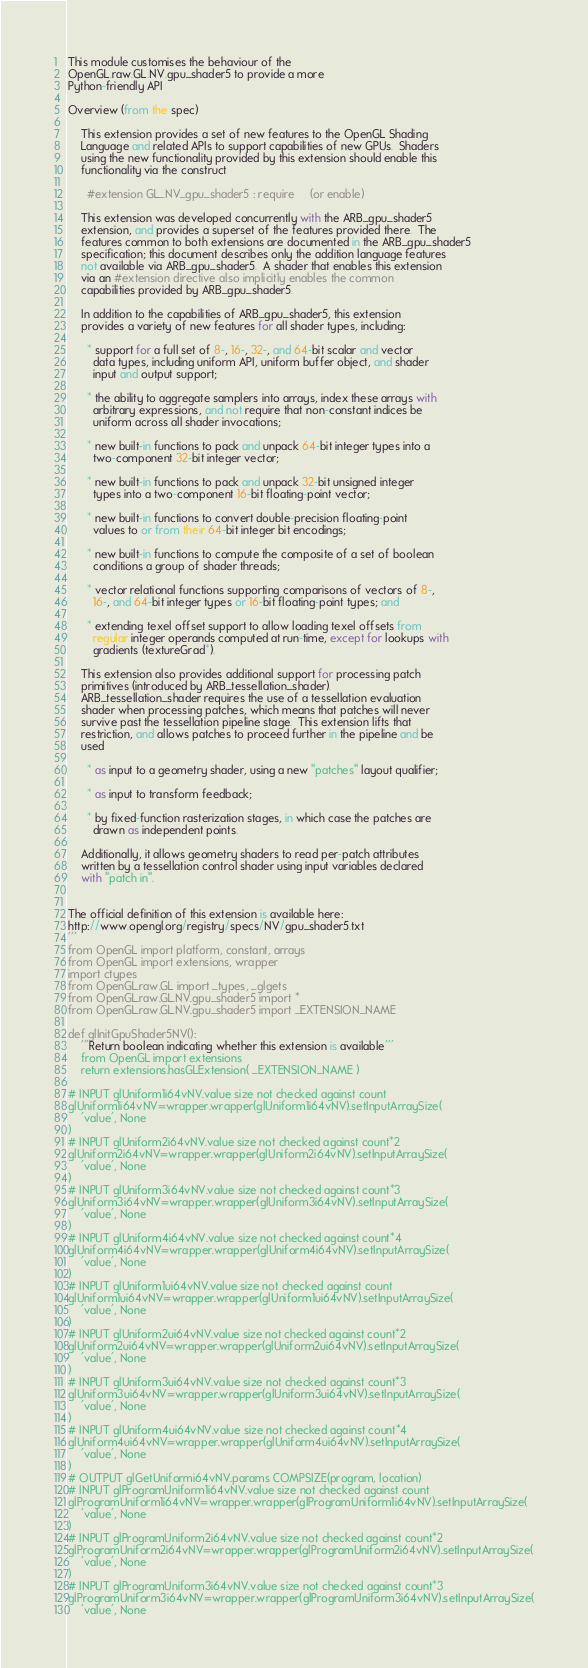Convert code to text. <code><loc_0><loc_0><loc_500><loc_500><_Python_>This module customises the behaviour of the 
OpenGL.raw.GL.NV.gpu_shader5 to provide a more 
Python-friendly API

Overview (from the spec)
	
	This extension provides a set of new features to the OpenGL Shading
	Language and related APIs to support capabilities of new GPUs.  Shaders
	using the new functionality provided by this extension should enable this
	functionality via the construct
	
	  #extension GL_NV_gpu_shader5 : require     (or enable)
	
	This extension was developed concurrently with the ARB_gpu_shader5
	extension, and provides a superset of the features provided there.  The
	features common to both extensions are documented in the ARB_gpu_shader5
	specification; this document describes only the addition language features
	not available via ARB_gpu_shader5.  A shader that enables this extension
	via an #extension directive also implicitly enables the common
	capabilities provided by ARB_gpu_shader5.
	
	In addition to the capabilities of ARB_gpu_shader5, this extension
	provides a variety of new features for all shader types, including:
	
	  * support for a full set of 8-, 16-, 32-, and 64-bit scalar and vector
	    data types, including uniform API, uniform buffer object, and shader
	    input and output support;
	
	  * the ability to aggregate samplers into arrays, index these arrays with
	    arbitrary expressions, and not require that non-constant indices be
	    uniform across all shader invocations;
	
	  * new built-in functions to pack and unpack 64-bit integer types into a
	    two-component 32-bit integer vector;
	
	  * new built-in functions to pack and unpack 32-bit unsigned integer
	    types into a two-component 16-bit floating-point vector;
	
	  * new built-in functions to convert double-precision floating-point
	    values to or from their 64-bit integer bit encodings;
	
	  * new built-in functions to compute the composite of a set of boolean
	    conditions a group of shader threads;
	
	  * vector relational functions supporting comparisons of vectors of 8-,
	    16-, and 64-bit integer types or 16-bit floating-point types; and
	
	  * extending texel offset support to allow loading texel offsets from
	    regular integer operands computed at run-time, except for lookups with
	    gradients (textureGrad*).
	
	This extension also provides additional support for processing patch
	primitives (introduced by ARB_tessellation_shader).
	ARB_tessellation_shader requires the use of a tessellation evaluation
	shader when processing patches, which means that patches will never
	survive past the tessellation pipeline stage.  This extension lifts that
	restriction, and allows patches to proceed further in the pipeline and be
	used
	
	  * as input to a geometry shader, using a new "patches" layout qualifier;
	
	  * as input to transform feedback;
	
	  * by fixed-function rasterization stages, in which case the patches are
	    drawn as independent points.
	
	Additionally, it allows geometry shaders to read per-patch attributes
	written by a tessellation control shader using input variables declared
	with "patch in".
	

The official definition of this extension is available here:
http://www.opengl.org/registry/specs/NV/gpu_shader5.txt
'''
from OpenGL import platform, constant, arrays
from OpenGL import extensions, wrapper
import ctypes
from OpenGL.raw.GL import _types, _glgets
from OpenGL.raw.GL.NV.gpu_shader5 import *
from OpenGL.raw.GL.NV.gpu_shader5 import _EXTENSION_NAME

def glInitGpuShader5NV():
    '''Return boolean indicating whether this extension is available'''
    from OpenGL import extensions
    return extensions.hasGLExtension( _EXTENSION_NAME )

# INPUT glUniform1i64vNV.value size not checked against count
glUniform1i64vNV=wrapper.wrapper(glUniform1i64vNV).setInputArraySize(
    'value', None
)
# INPUT glUniform2i64vNV.value size not checked against count*2
glUniform2i64vNV=wrapper.wrapper(glUniform2i64vNV).setInputArraySize(
    'value', None
)
# INPUT glUniform3i64vNV.value size not checked against count*3
glUniform3i64vNV=wrapper.wrapper(glUniform3i64vNV).setInputArraySize(
    'value', None
)
# INPUT glUniform4i64vNV.value size not checked against count*4
glUniform4i64vNV=wrapper.wrapper(glUniform4i64vNV).setInputArraySize(
    'value', None
)
# INPUT glUniform1ui64vNV.value size not checked against count
glUniform1ui64vNV=wrapper.wrapper(glUniform1ui64vNV).setInputArraySize(
    'value', None
)
# INPUT glUniform2ui64vNV.value size not checked against count*2
glUniform2ui64vNV=wrapper.wrapper(glUniform2ui64vNV).setInputArraySize(
    'value', None
)
# INPUT glUniform3ui64vNV.value size not checked against count*3
glUniform3ui64vNV=wrapper.wrapper(glUniform3ui64vNV).setInputArraySize(
    'value', None
)
# INPUT glUniform4ui64vNV.value size not checked against count*4
glUniform4ui64vNV=wrapper.wrapper(glUniform4ui64vNV).setInputArraySize(
    'value', None
)
# OUTPUT glGetUniformi64vNV.params COMPSIZE(program, location) 
# INPUT glProgramUniform1i64vNV.value size not checked against count
glProgramUniform1i64vNV=wrapper.wrapper(glProgramUniform1i64vNV).setInputArraySize(
    'value', None
)
# INPUT glProgramUniform2i64vNV.value size not checked against count*2
glProgramUniform2i64vNV=wrapper.wrapper(glProgramUniform2i64vNV).setInputArraySize(
    'value', None
)
# INPUT glProgramUniform3i64vNV.value size not checked against count*3
glProgramUniform3i64vNV=wrapper.wrapper(glProgramUniform3i64vNV).setInputArraySize(
    'value', None</code> 